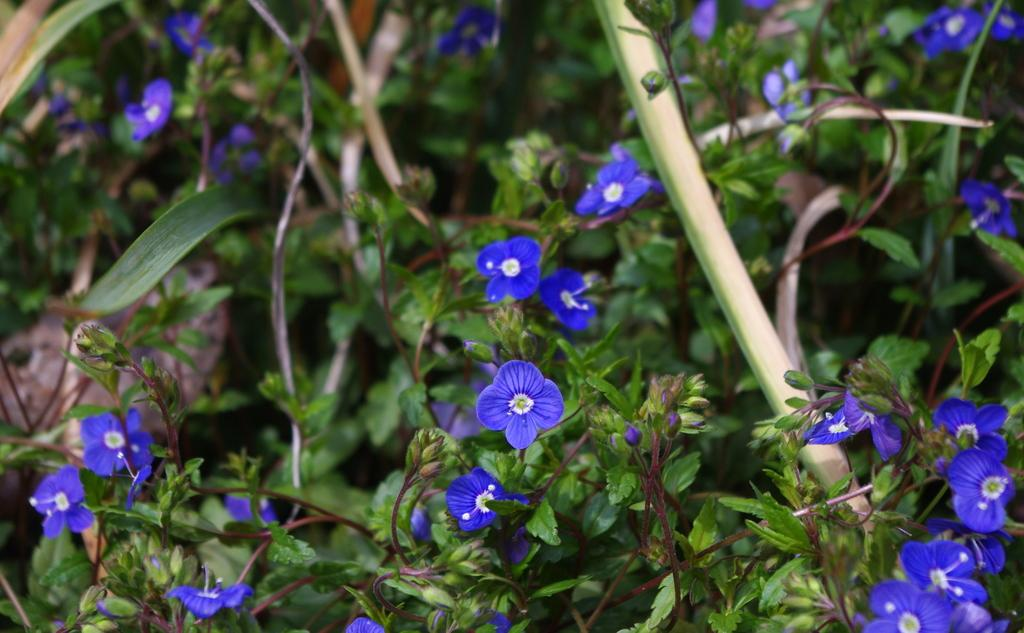What types of vegetation can be seen in the image? There are many plants, flowers, and leaves in the image. Can you describe the specific types of flowers in the image? Unfortunately, the specific types of flowers cannot be determined from the image alone. What part of the plants can be seen in the image? Leaves are visible in the image. What type of war is being depicted in the image? There is no depiction of war in the image; it features plants, flowers, and leaves. How many birds are visible in the image? There are no birds present in the image. 